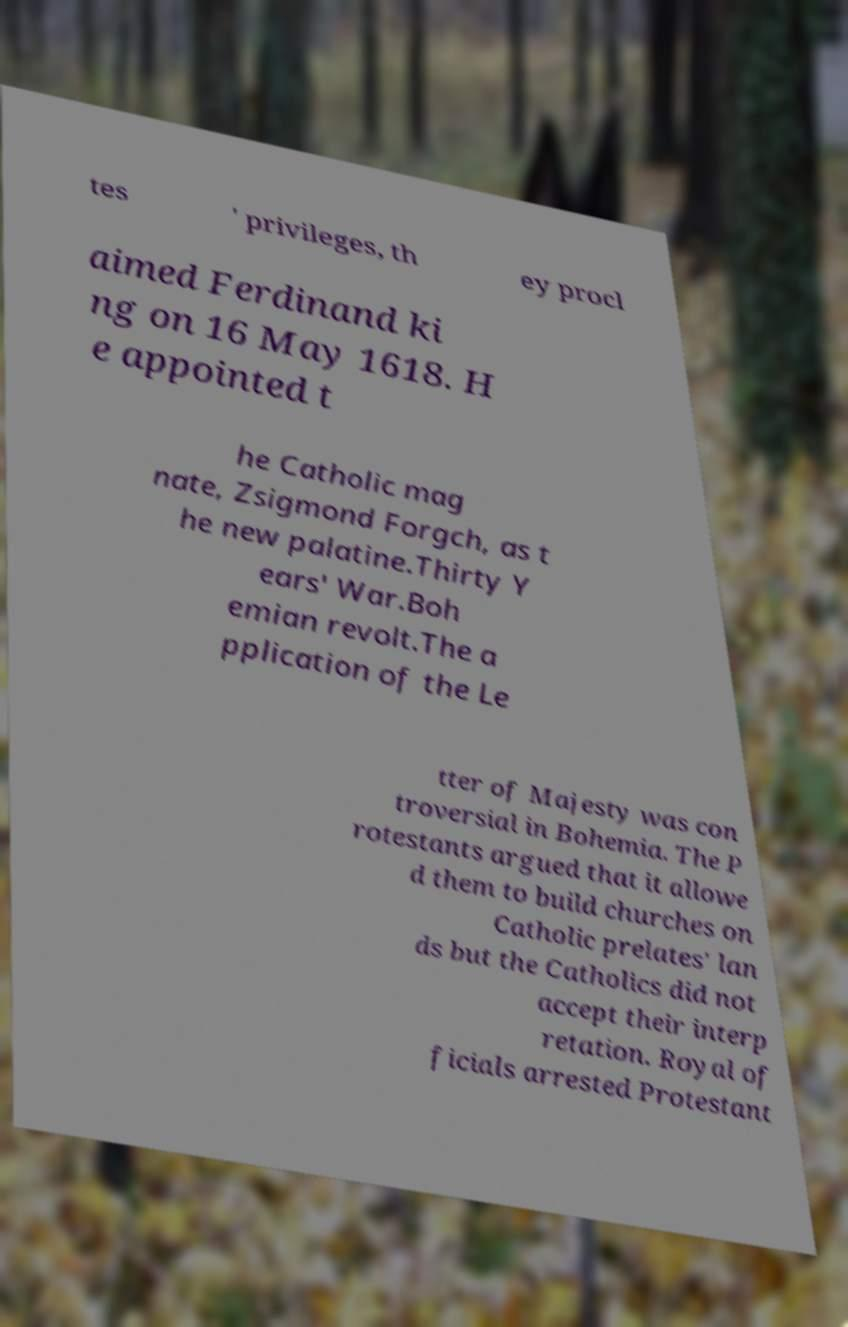Can you accurately transcribe the text from the provided image for me? tes ' privileges, th ey procl aimed Ferdinand ki ng on 16 May 1618. H e appointed t he Catholic mag nate, Zsigmond Forgch, as t he new palatine.Thirty Y ears' War.Boh emian revolt.The a pplication of the Le tter of Majesty was con troversial in Bohemia. The P rotestants argued that it allowe d them to build churches on Catholic prelates' lan ds but the Catholics did not accept their interp retation. Royal of ficials arrested Protestant 